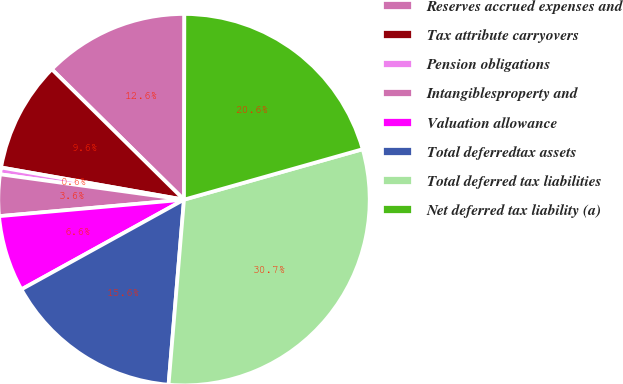Convert chart to OTSL. <chart><loc_0><loc_0><loc_500><loc_500><pie_chart><fcel>Reserves accrued expenses and<fcel>Tax attribute carryovers<fcel>Pension obligations<fcel>Intangiblesproperty and<fcel>Valuation allowance<fcel>Total deferredtax assets<fcel>Total deferred tax liabilities<fcel>Net deferred tax liability (a)<nl><fcel>12.64%<fcel>9.62%<fcel>0.59%<fcel>3.6%<fcel>6.61%<fcel>15.65%<fcel>30.71%<fcel>20.59%<nl></chart> 